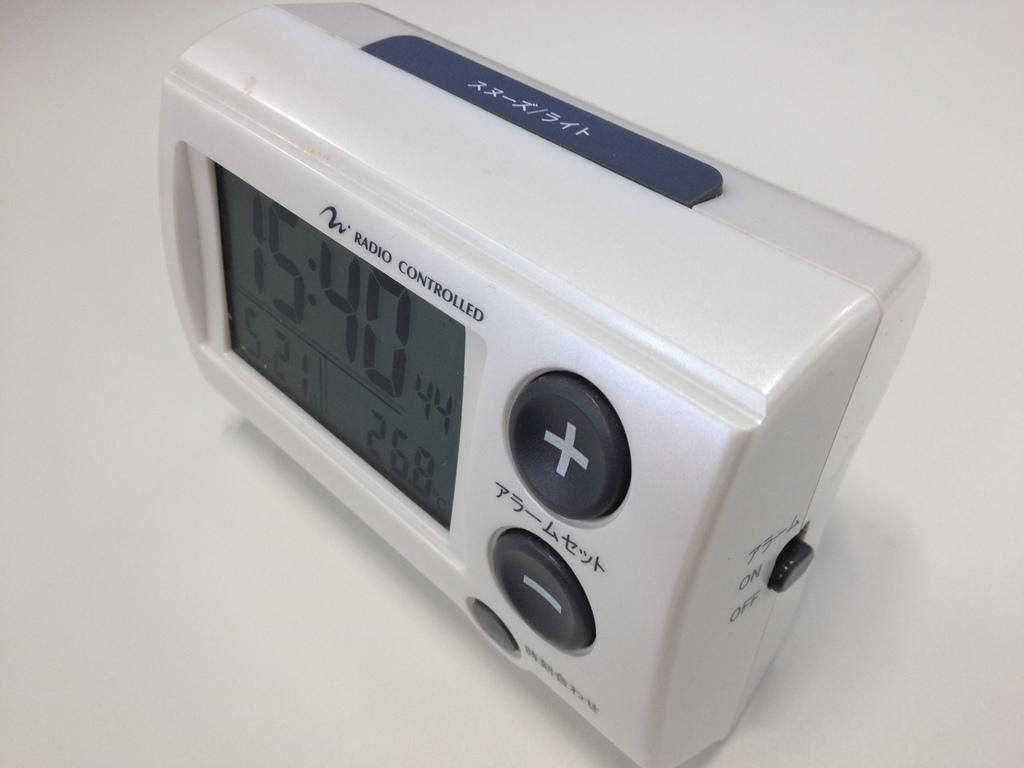<image>
Render a clear and concise summary of the photo. a digital clock from Radio Controlled also has Japanese letters on it 